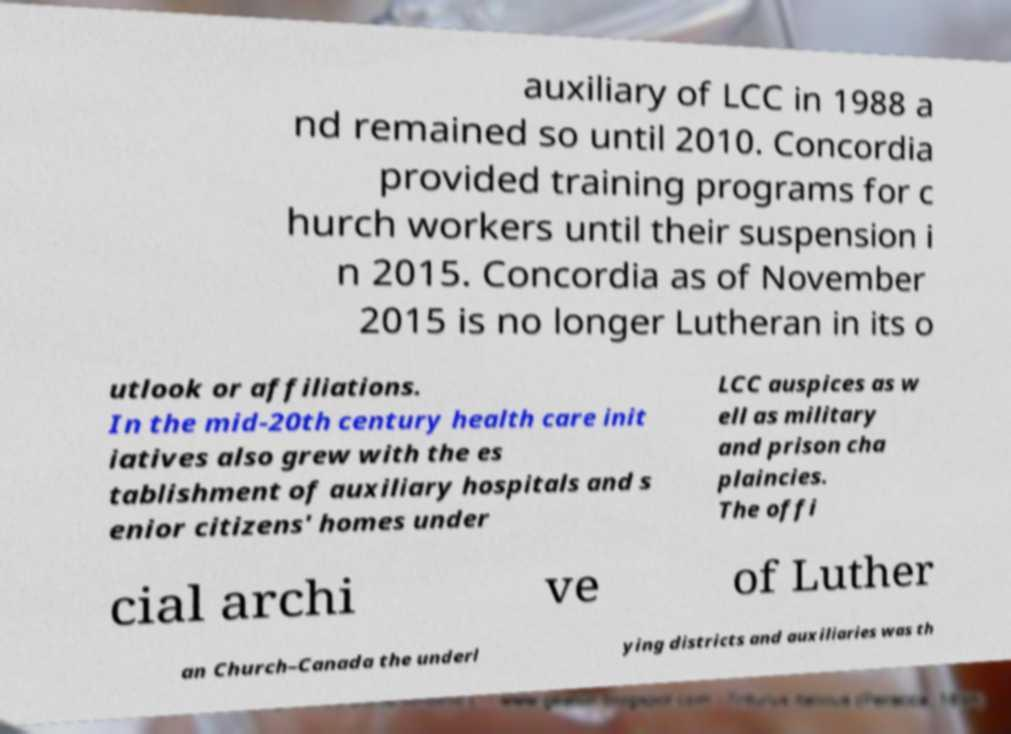What messages or text are displayed in this image? I need them in a readable, typed format. auxiliary of LCC in 1988 a nd remained so until 2010. Concordia provided training programs for c hurch workers until their suspension i n 2015. Concordia as of November 2015 is no longer Lutheran in its o utlook or affiliations. In the mid-20th century health care init iatives also grew with the es tablishment of auxiliary hospitals and s enior citizens' homes under LCC auspices as w ell as military and prison cha plaincies. The offi cial archi ve of Luther an Church–Canada the underl ying districts and auxiliaries was th 